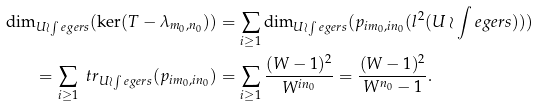Convert formula to latex. <formula><loc_0><loc_0><loc_500><loc_500>\dim _ { U \wr \int e g e r s } ( \ker ( T - \lambda _ { m _ { 0 } , n _ { 0 } } ) ) & = \sum _ { i \geq 1 } \dim _ { U \wr \int e g e r s } ( p _ { i m _ { 0 } , i n _ { 0 } } ( l ^ { 2 } ( U \wr \int e g e r s ) ) ) \\ = \sum _ { i \geq 1 } \ t r _ { U \wr \int e g e r s } ( p _ { i m _ { 0 } , i n _ { 0 } } ) & = \sum _ { i \geq 1 } \frac { ( W - 1 ) ^ { 2 } } { W ^ { i n _ { 0 } } } = \frac { ( W - 1 ) ^ { 2 } } { W ^ { n _ { 0 } } - 1 } .</formula> 